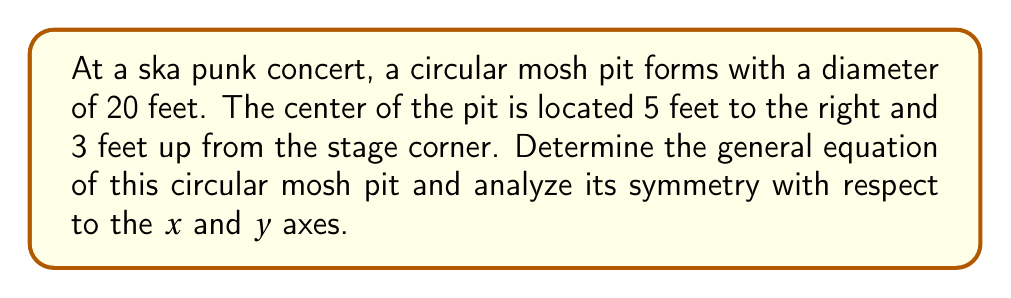Teach me how to tackle this problem. Let's approach this step-by-step:

1) The general equation of a circle is:
   $$(x - h)^2 + (y - k)^2 = r^2$$
   where $(h,k)$ is the center and $r$ is the radius.

2) We're given that the center is 5 feet right and 3 feet up from the origin (stage corner).
   So, $h = 5$ and $k = 3$

3) The diameter is 20 feet, so the radius is 10 feet.
   $r = 10$

4) Substituting these values into the general equation:
   $$(x - 5)^2 + (y - 3)^2 = 10^2$$

5) Expanding this:
   $$(x - 5)^2 + (y - 3)^2 = 100$$

6) To analyze symmetry, we need to consider the following:
   - A circle is symmetric about any line that passes through its center.
   - The x-axis has the equation $y = 0$
   - The y-axis has the equation $x = 0$

7) For x-axis symmetry:
   The center is 3 units above the x-axis. The mosh pit is not symmetric about the x-axis.

8) For y-axis symmetry:
   The center is 5 units to the right of the y-axis. The mosh pit is not symmetric about the y-axis.

9) However, the mosh pit is symmetric about the vertical line $x = 5$ and the horizontal line $y = 3$, which pass through its center.

[asy]
size(200);
draw(circle((5,3),10));
draw((-2,0)--(12,0),arrow=Arrow(TeXHead));
draw((0,-2)--(0,8),arrow=Arrow(TeXHead));
dot((5,3));
label("(5,3)",(5,3),NE);
label("x",((12,0)),E);
label("y",(0,8),N);
[/asy]
Answer: $(x - 5)^2 + (y - 3)^2 = 100$; Not symmetric about x or y axes 